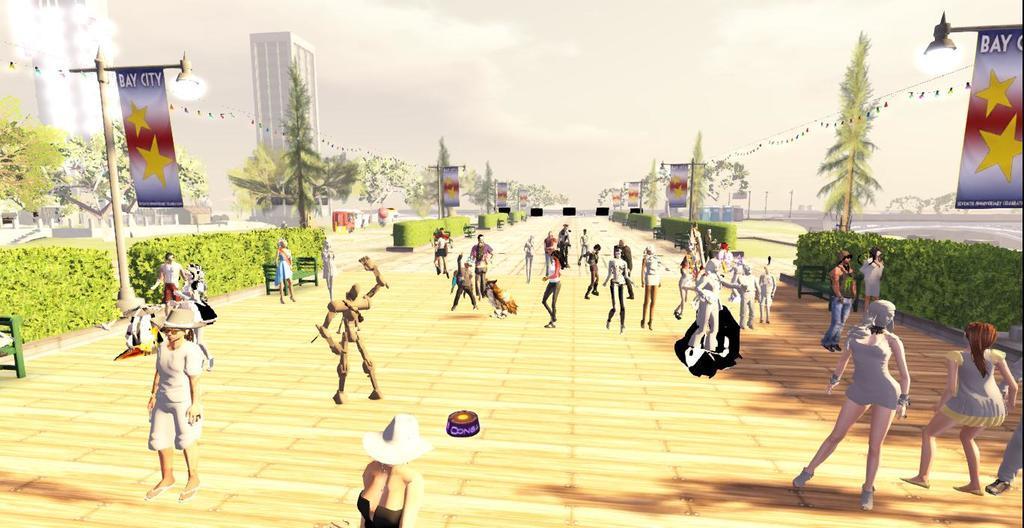How would you summarize this image in a sentence or two? This is animated picture we can see people,benches, lights and banners on poles and we can see plants. In the background we can see building,trees and sky. 